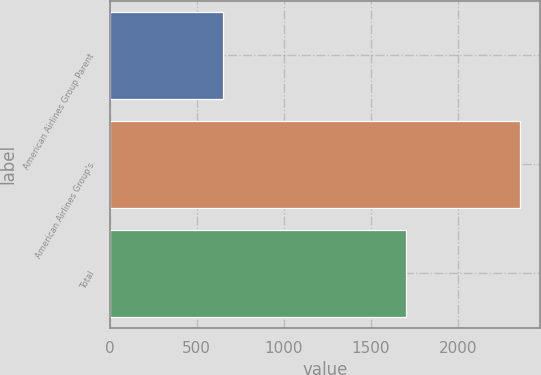Convert chart. <chart><loc_0><loc_0><loc_500><loc_500><bar_chart><fcel>American Airlines Group Parent<fcel>American Airlines Group's<fcel>Total<nl><fcel>653<fcel>2356<fcel>1703<nl></chart> 